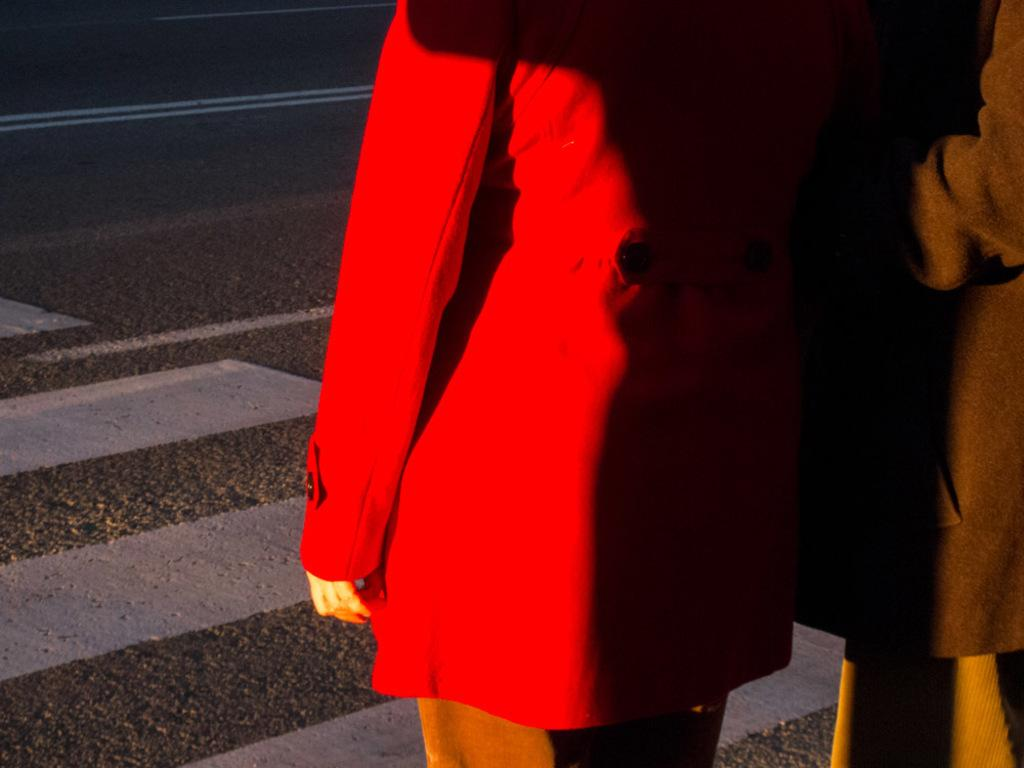How many people are in the foreground of the image? There are two persons standing in the foreground of the image. What is the setting where the persons are standing? The persons are standing on a road. What is the weather like in the image? The image was taken during a sunny day. What arithmetic problem are the persons solving together in the image? There is no indication in the image that the persons are solving an arithmetic problem together. 